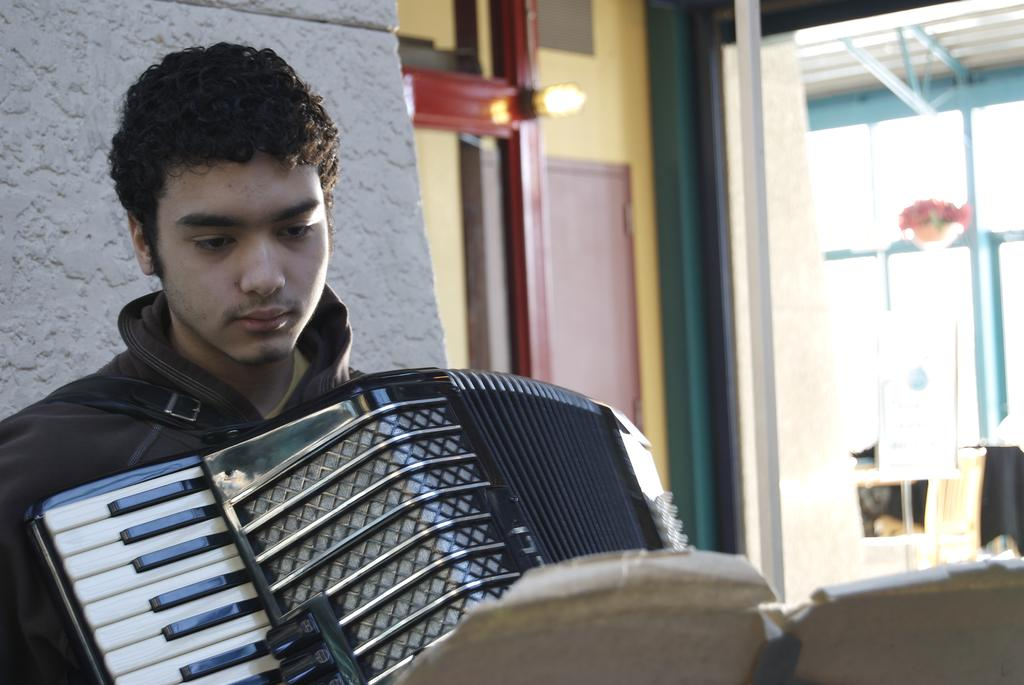Who is in the image? There is a boy in the image. What is the boy holding in the image? The boy is holding a musical instrument. What is in front of the boy? There is a book in front of the boy. What can be seen in the background of the image? There is a wall, a door, and a flower in the background of the image. What type of scent can be detected from the quince in the image? There is no quince present in the image, so it is not possible to detect any scent. 